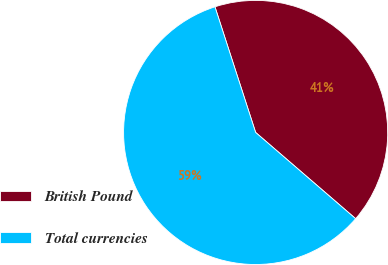Convert chart to OTSL. <chart><loc_0><loc_0><loc_500><loc_500><pie_chart><fcel>British Pound<fcel>Total currencies<nl><fcel>41.31%<fcel>58.69%<nl></chart> 